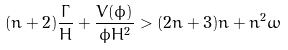Convert formula to latex. <formula><loc_0><loc_0><loc_500><loc_500>( n + 2 ) \frac { \Gamma } { H } + \frac { V ( \phi ) } { \phi H ^ { 2 } } > ( 2 n + 3 ) n + n ^ { 2 } \omega</formula> 